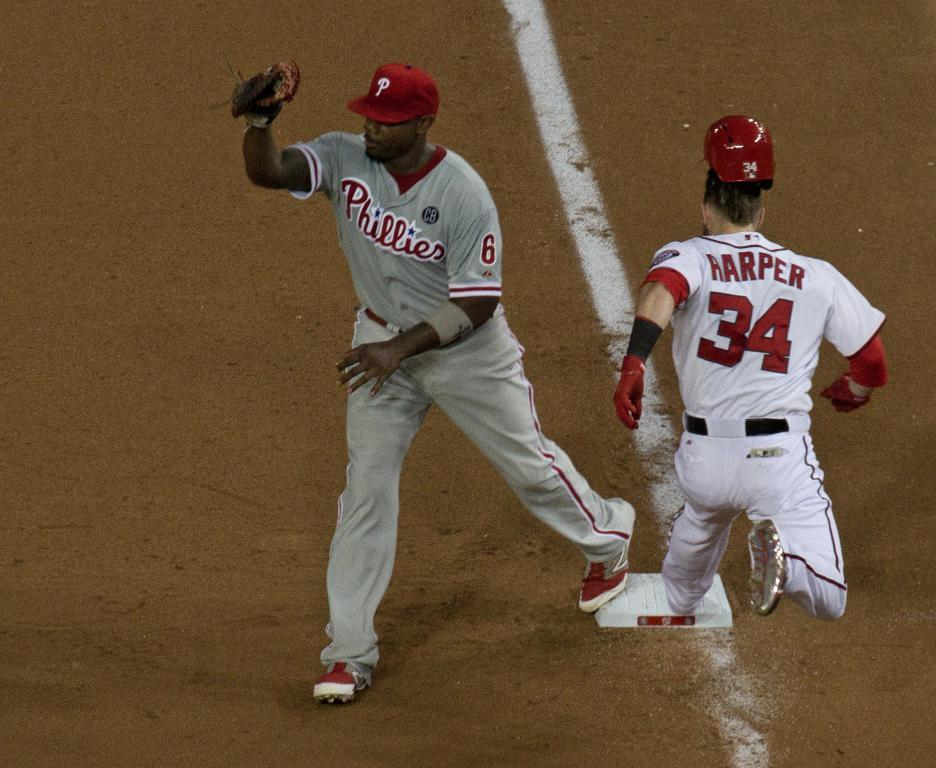Provide a one-sentence caption for the provided image. Stealing that first base from the Phillies baseman. 